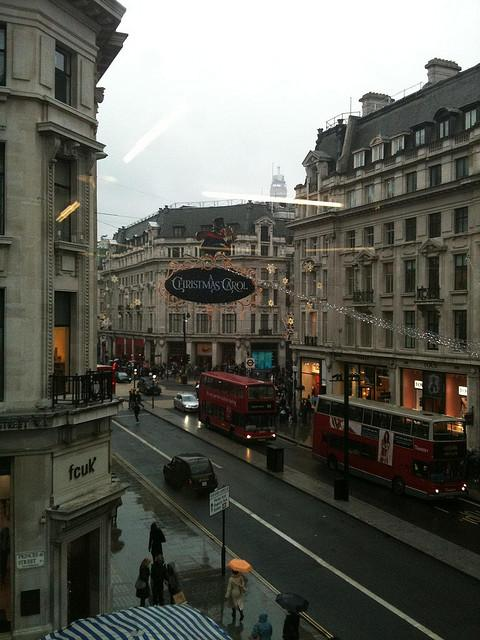Why is the woman carrying an orange umbrella? Please explain your reasoning. it's raining. It's obvious from the wet street that it's raining, so the woman has opened her umbrella. it's orange because she likes the color and isn't afraid of people looking at her!. 